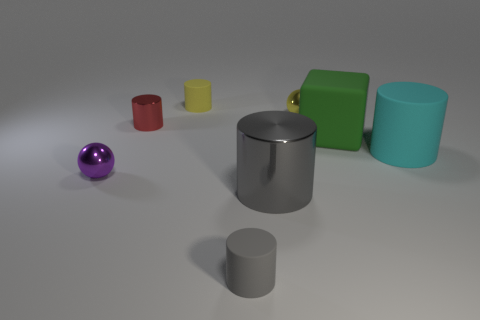There is a small metallic sphere that is behind the tiny cylinder left of the matte thing behind the yellow metal thing; what is its color? The small metallic sphere in question has a purple hue. It's situated behind the diminutive silver cylinder to the left of the green matte cube, which in turn is behind the yellow metallic cylinder. 